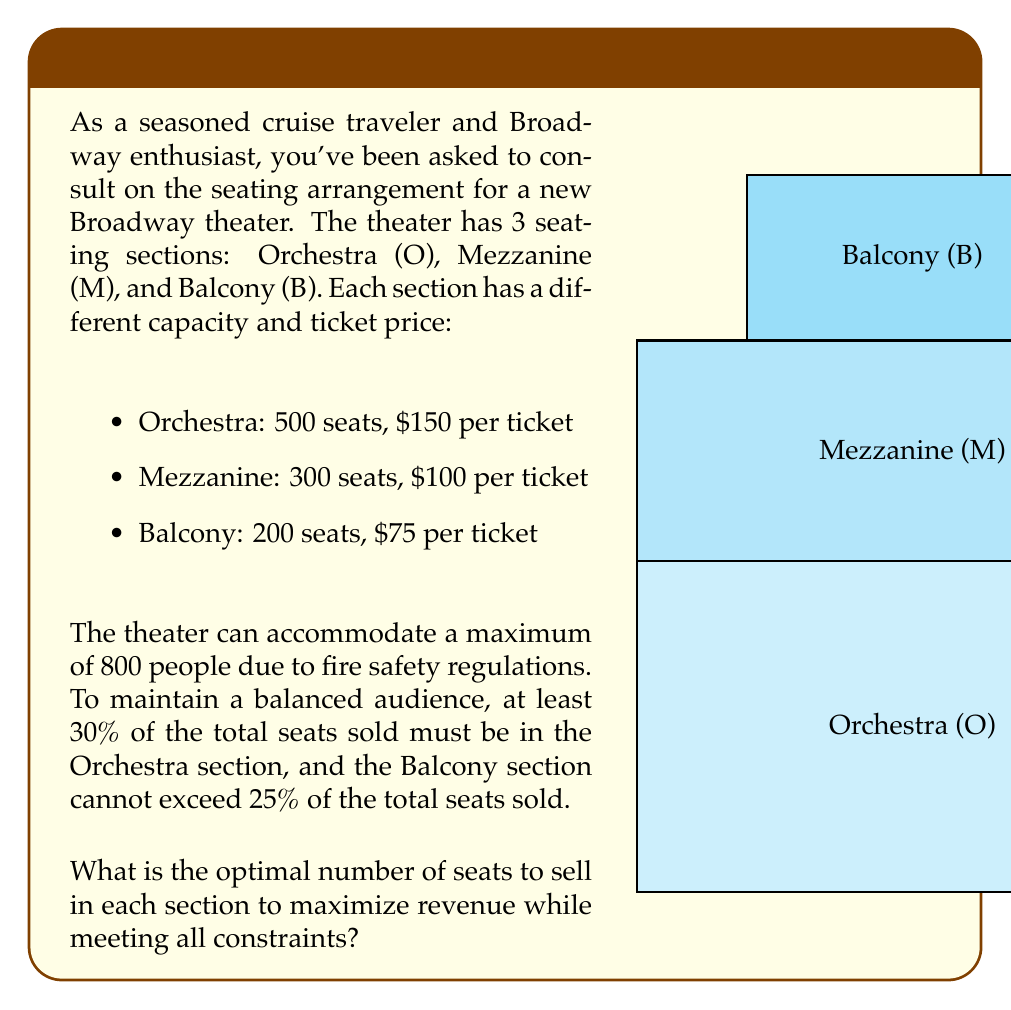Teach me how to tackle this problem. Let's approach this step-by-step using linear programming:

1) Define variables:
   $x_O$ = number of Orchestra seats sold
   $x_M$ = number of Mezzanine seats sold
   $x_B$ = number of Balcony seats sold

2) Objective function (maximize revenue):
   $\text{Max } Z = 150x_O + 100x_M + 75x_B$

3) Constraints:
   a) Capacity constraints:
      $x_O \leq 500$
      $x_M \leq 300$
      $x_B \leq 200$

   b) Total seats constraint:
      $x_O + x_M + x_B \leq 800$

   c) Orchestra seats at least 30% of total:
      $x_O \geq 0.3(x_O + x_M + x_B)$

   d) Balcony seats at most 25% of total:
      $x_B \leq 0.25(x_O + x_M + x_B)$

   e) Non-negativity:
      $x_O, x_M, x_B \geq 0$

4) Simplify constraints c and d:
   $0.7x_O - 0.3x_M - 0.3x_B \geq 0$
   $-0.25x_O - 0.25x_M + 0.75x_B \leq 0$

5) Solve using the simplex method or linear programming software.

6) The optimal solution is:
   $x_O = 400$, $x_M = 300$, $x_B = 100$

7) Check constraints:
   - All capacity constraints are met
   - Total seats: 400 + 300 + 100 = 800 (maximum allowed)
   - Orchestra: 400/800 = 50% > 30%
   - Balcony: 100/800 = 12.5% < 25%

8) Calculate maximum revenue:
   $Z = 150(400) + 100(300) + 75(100) = 60,000 + 30,000 + 7,500 = 97,500$

Therefore, the optimal seating arrangement is 400 Orchestra seats, 300 Mezzanine seats, and 100 Balcony seats, generating a maximum revenue of $97,500.
Answer: Orchestra: 400, Mezzanine: 300, Balcony: 100 